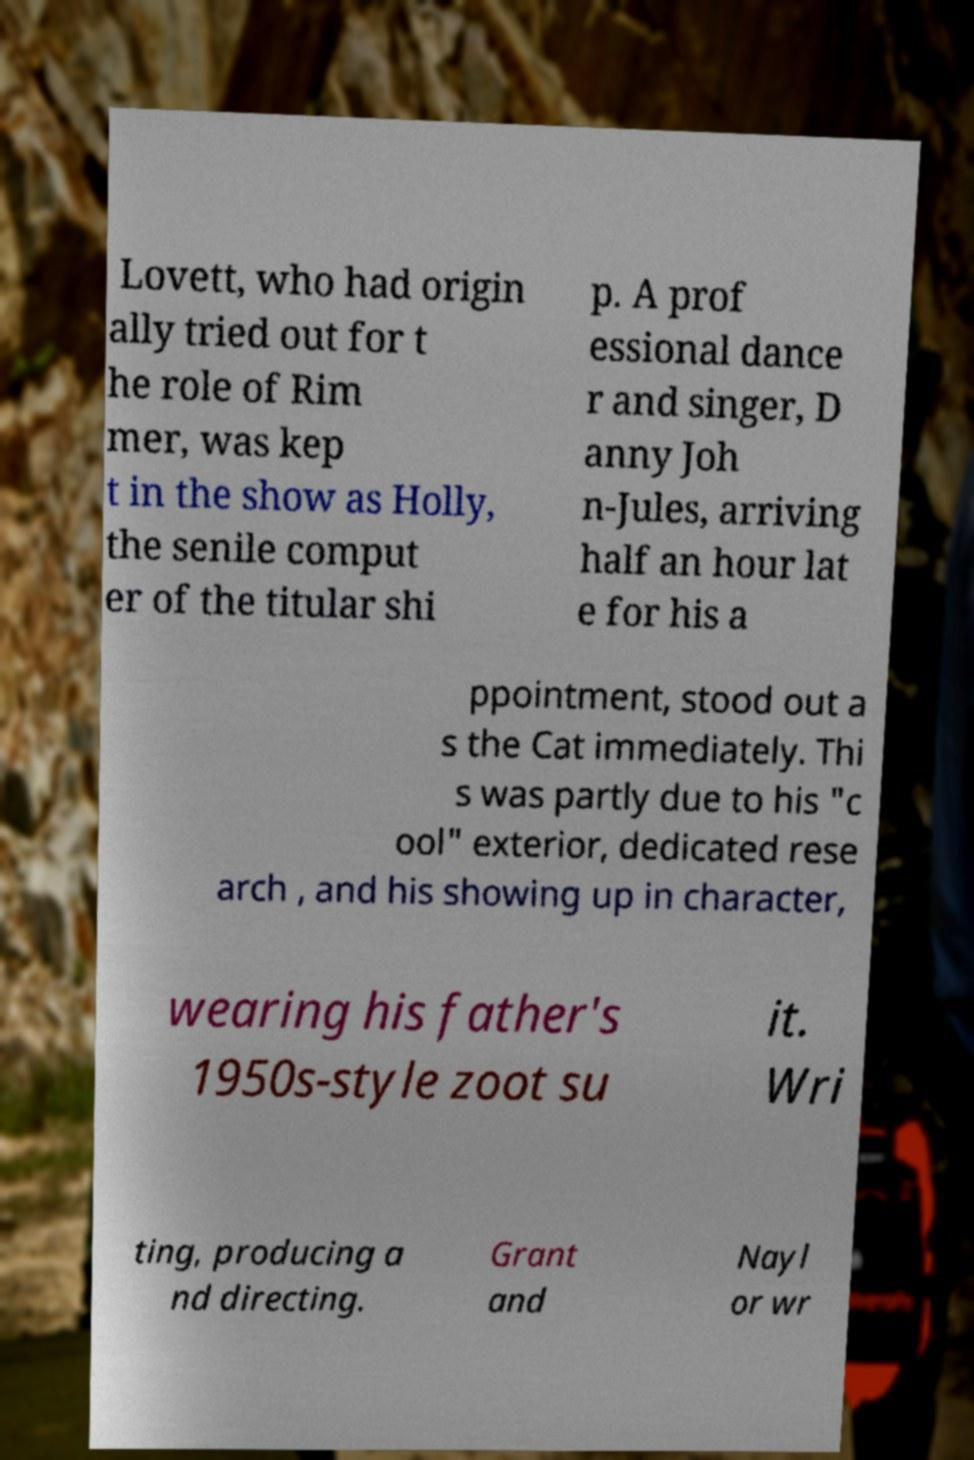For documentation purposes, I need the text within this image transcribed. Could you provide that? Lovett, who had origin ally tried out for t he role of Rim mer, was kep t in the show as Holly, the senile comput er of the titular shi p. A prof essional dance r and singer, D anny Joh n-Jules, arriving half an hour lat e for his a ppointment, stood out a s the Cat immediately. Thi s was partly due to his "c ool" exterior, dedicated rese arch , and his showing up in character, wearing his father's 1950s-style zoot su it. Wri ting, producing a nd directing. Grant and Nayl or wr 